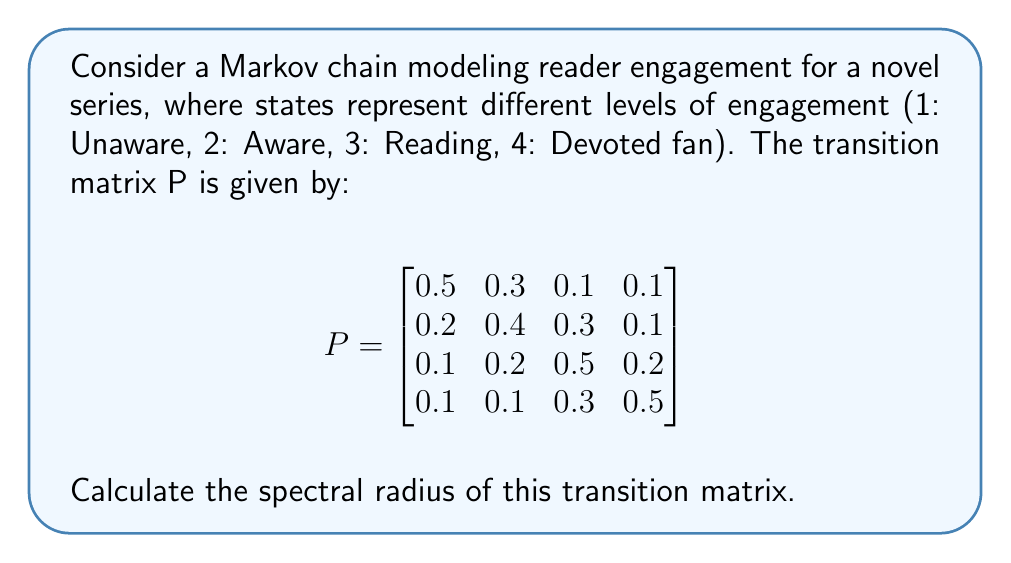Give your solution to this math problem. To calculate the spectral radius of the transition matrix P, we need to follow these steps:

1) The spectral radius is the largest absolute value of the eigenvalues of P.

2) To find the eigenvalues, we need to solve the characteristic equation:
   $\det(P - \lambda I) = 0$

3) Expanding the determinant:
   $$\begin{vmatrix}
   0.5-\lambda & 0.3 & 0.1 & 0.1 \\
   0.2 & 0.4-\lambda & 0.3 & 0.1 \\
   0.1 & 0.2 & 0.5-\lambda & 0.2 \\
   0.1 & 0.1 & 0.3 & 0.5-\lambda
   \end{vmatrix} = 0$$

4) This leads to the characteristic polynomial:
   $\lambda^4 - 1.9\lambda^3 + 1.07\lambda^2 - 0.2145\lambda + 0.0145 = 0$

5) The roots of this polynomial are the eigenvalues. For a 4x4 matrix, finding these roots analytically is complex, so we typically use numerical methods.

6) Using a numerical solver, we find the eigenvalues:
   $\lambda_1 \approx 1$
   $\lambda_2 \approx 0.4472$
   $\lambda_3 \approx 0.2264 + 0.1368i$
   $\lambda_4 \approx 0.2264 - 0.1368i$

7) The spectral radius is the maximum absolute value among these eigenvalues.

8) $|\lambda_1| = 1$
   $|\lambda_2| \approx 0.4472$
   $|\lambda_3| = |\lambda_4| \approx \sqrt{0.2264^2 + 0.1368^2} \approx 0.2646$

9) Therefore, the spectral radius is 1.

Note: The spectral radius of a stochastic matrix (like this transition matrix) is always 1, which serves as a good check for our calculation.
Answer: 1 